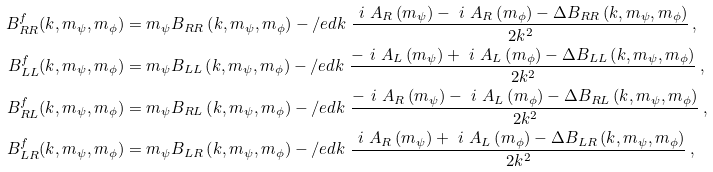Convert formula to latex. <formula><loc_0><loc_0><loc_500><loc_500>B ^ { f } _ { R R } ( k , m _ { \psi } , m _ { \phi } ) & = m _ { \psi } B _ { R R } \left ( k , m _ { \psi } , m _ { \phi } \right ) - \slash e d { k } \ \frac { \ i \ A _ { R } \left ( m _ { \psi } \right ) - \ i \ A _ { R } \left ( m _ { \phi } \right ) - \Delta B _ { R R } \left ( k , m _ { \psi } , m _ { \phi } \right ) } { 2 k ^ { 2 } } \, , \\ B ^ { f } _ { L L } ( k , m _ { \psi } , m _ { \phi } ) & = m _ { \psi } B _ { L L } \left ( k , m _ { \psi } , m _ { \phi } \right ) - \slash e d { k } \ \frac { - \ i \ A _ { L } \left ( m _ { \psi } \right ) + \ i \ A _ { L } \left ( m _ { \phi } \right ) - \Delta B _ { L L } \left ( k , m _ { \psi } , m _ { \phi } \right ) } { 2 k ^ { 2 } } \, , \\ B ^ { f } _ { R L } ( k , m _ { \psi } , m _ { \phi } ) & = m _ { \psi } B _ { R L } \left ( k , m _ { \psi } , m _ { \phi } \right ) - \slash e d { k } \ \frac { - \ i \ A _ { R } \left ( m _ { \psi } \right ) - \ i \ A _ { L } \left ( m _ { \phi } \right ) - \Delta B _ { R L } \left ( k , m _ { \psi } , m _ { \phi } \right ) } { 2 k ^ { 2 } } \, , \\ B ^ { f } _ { L R } ( k , m _ { \psi } , m _ { \phi } ) & = m _ { \psi } B _ { L R } \left ( k , m _ { \psi } , m _ { \phi } \right ) - \slash e d { k } \ \frac { \ i \ A _ { R } \left ( m _ { \psi } \right ) + \ i \ A _ { L } \left ( m _ { \phi } \right ) - \Delta B _ { L R } \left ( k , m _ { \psi } , m _ { \phi } \right ) } { 2 k ^ { 2 } } \, ,</formula> 